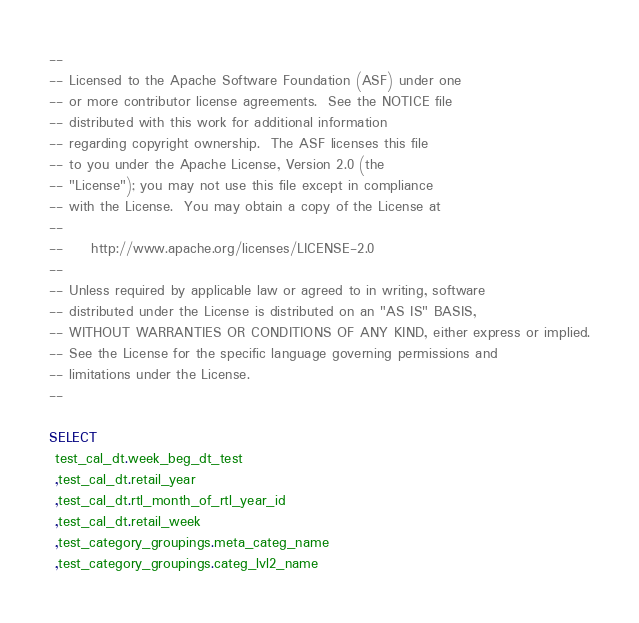Convert code to text. <code><loc_0><loc_0><loc_500><loc_500><_SQL_>--
-- Licensed to the Apache Software Foundation (ASF) under one
-- or more contributor license agreements.  See the NOTICE file
-- distributed with this work for additional information
-- regarding copyright ownership.  The ASF licenses this file
-- to you under the Apache License, Version 2.0 (the
-- "License"); you may not use this file except in compliance
-- with the License.  You may obtain a copy of the License at
--
--     http://www.apache.org/licenses/LICENSE-2.0
--
-- Unless required by applicable law or agreed to in writing, software
-- distributed under the License is distributed on an "AS IS" BASIS,
-- WITHOUT WARRANTIES OR CONDITIONS OF ANY KIND, either express or implied.
-- See the License for the specific language governing permissions and
-- limitations under the License.
--

SELECT 
 test_cal_dt.week_beg_dt_test 
 ,test_cal_dt.retail_year 
 ,test_cal_dt.rtl_month_of_rtl_year_id 
 ,test_cal_dt.retail_week 
 ,test_category_groupings.meta_categ_name 
 ,test_category_groupings.categ_lvl2_name </code> 